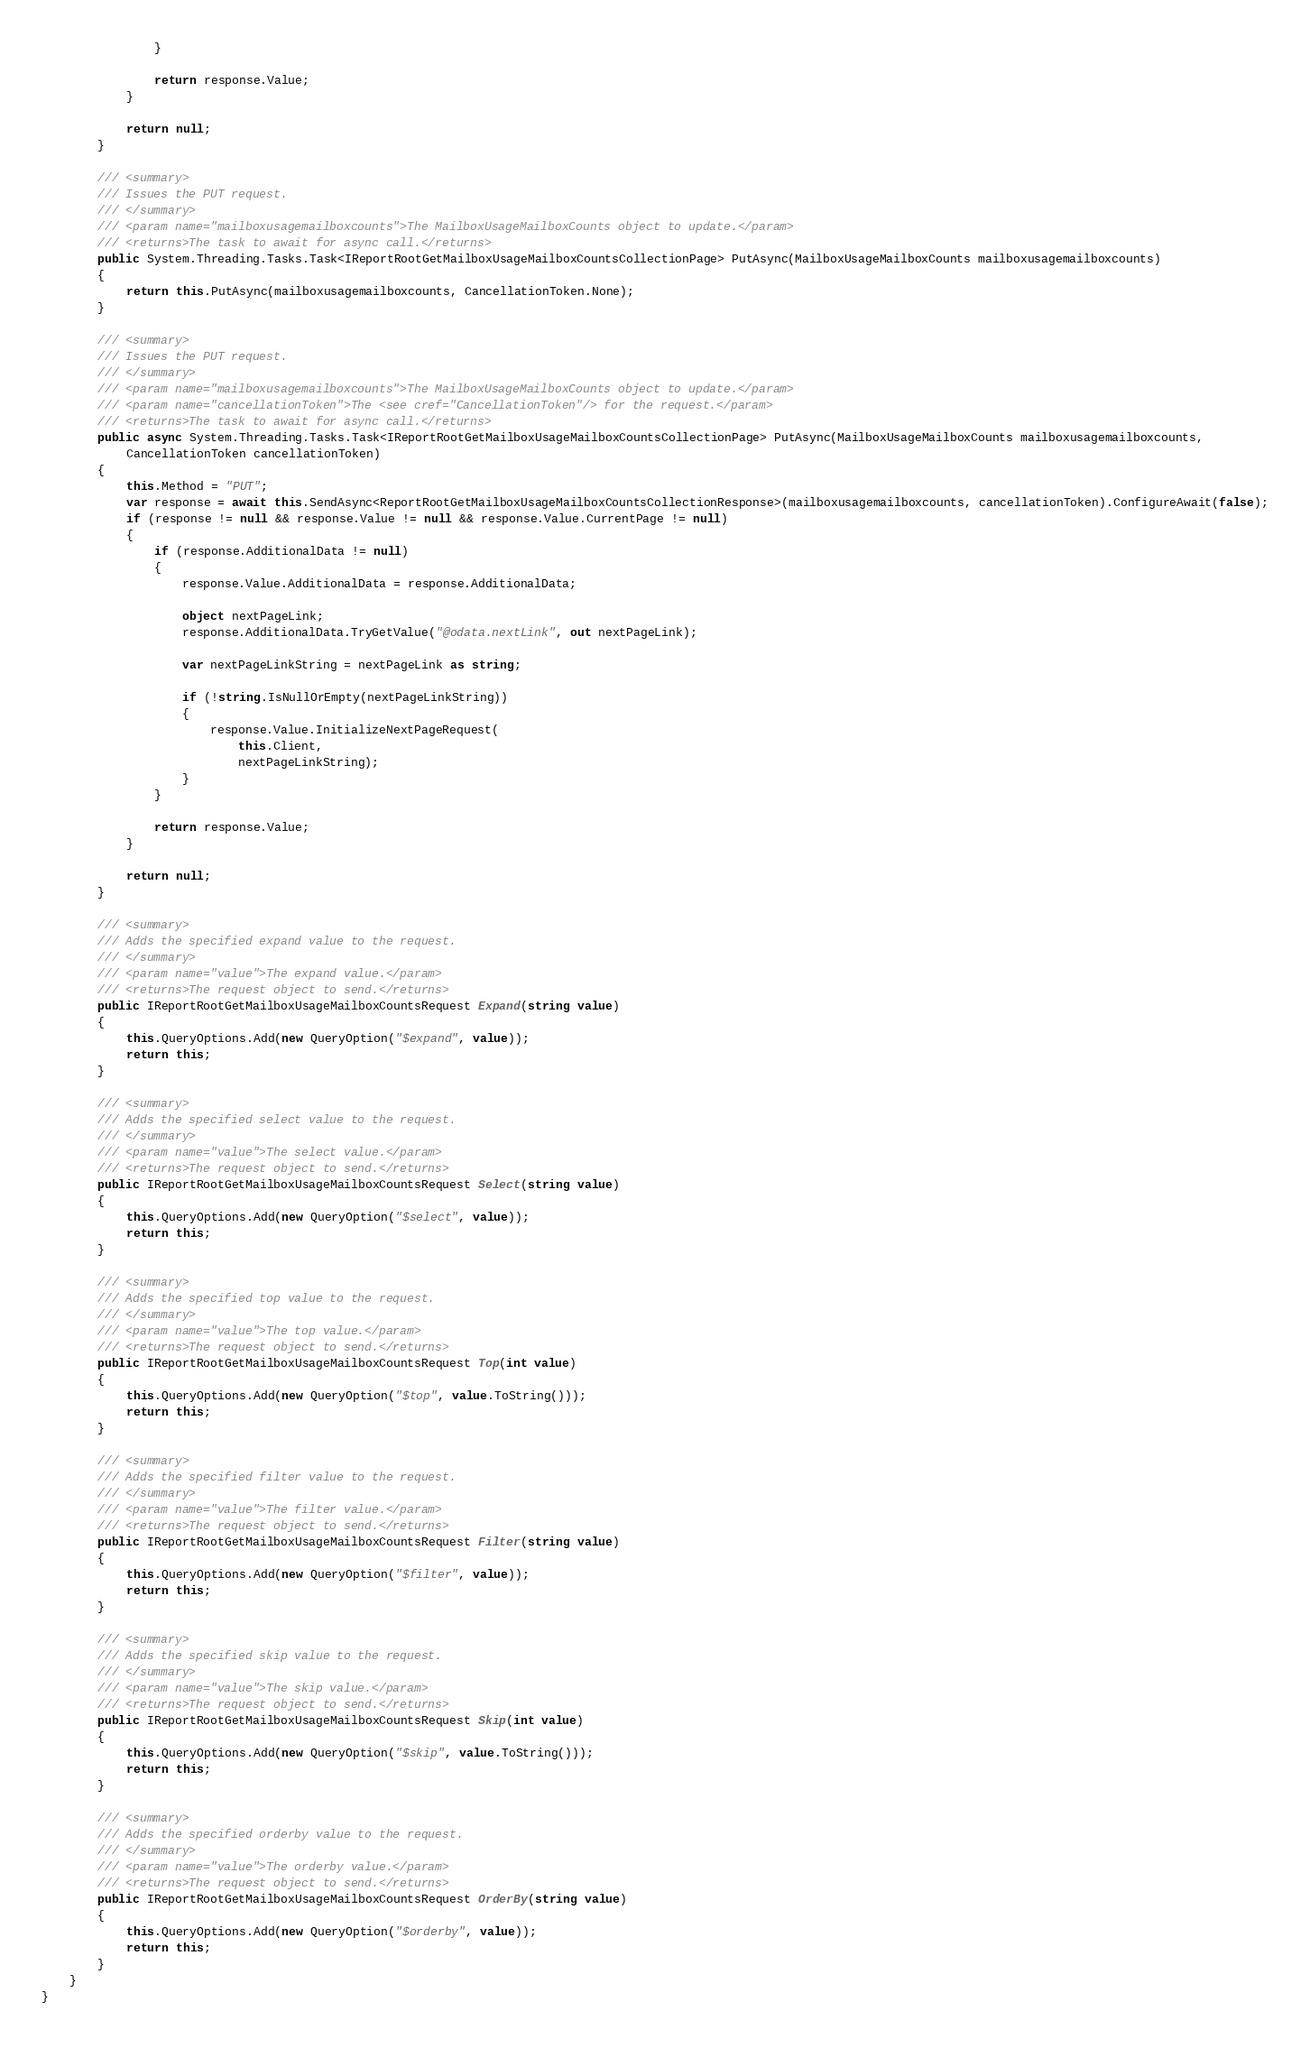Convert code to text. <code><loc_0><loc_0><loc_500><loc_500><_C#_>                }

                return response.Value;
            }

            return null;
        }        

        /// <summary>
        /// Issues the PUT request.
        /// </summary>
        /// <param name="mailboxusagemailboxcounts">The MailboxUsageMailboxCounts object to update.</param>
        /// <returns>The task to await for async call.</returns>
        public System.Threading.Tasks.Task<IReportRootGetMailboxUsageMailboxCountsCollectionPage> PutAsync(MailboxUsageMailboxCounts mailboxusagemailboxcounts)
        {
            return this.PutAsync(mailboxusagemailboxcounts, CancellationToken.None);
        }

        /// <summary>
        /// Issues the PUT request.
        /// </summary>
        /// <param name="mailboxusagemailboxcounts">The MailboxUsageMailboxCounts object to update.</param>
        /// <param name="cancellationToken">The <see cref="CancellationToken"/> for the request.</param>
        /// <returns>The task to await for async call.</returns>
        public async System.Threading.Tasks.Task<IReportRootGetMailboxUsageMailboxCountsCollectionPage> PutAsync(MailboxUsageMailboxCounts mailboxusagemailboxcounts, 
            CancellationToken cancellationToken)
        {
            this.Method = "PUT";
            var response = await this.SendAsync<ReportRootGetMailboxUsageMailboxCountsCollectionResponse>(mailboxusagemailboxcounts, cancellationToken).ConfigureAwait(false);
            if (response != null && response.Value != null && response.Value.CurrentPage != null)
            {
                if (response.AdditionalData != null)
                {
                    response.Value.AdditionalData = response.AdditionalData;

                    object nextPageLink;
                    response.AdditionalData.TryGetValue("@odata.nextLink", out nextPageLink);

                    var nextPageLinkString = nextPageLink as string;

                    if (!string.IsNullOrEmpty(nextPageLinkString))
                    {
                        response.Value.InitializeNextPageRequest(
                            this.Client,
                            nextPageLinkString);
                    }
                }

                return response.Value;
            }

            return null;
        }        

        /// <summary>
        /// Adds the specified expand value to the request.
        /// </summary>
        /// <param name="value">The expand value.</param>
        /// <returns>The request object to send.</returns>
        public IReportRootGetMailboxUsageMailboxCountsRequest Expand(string value)
        {
            this.QueryOptions.Add(new QueryOption("$expand", value));
            return this;
        }

        /// <summary>
        /// Adds the specified select value to the request.
        /// </summary>
        /// <param name="value">The select value.</param>
        /// <returns>The request object to send.</returns>
        public IReportRootGetMailboxUsageMailboxCountsRequest Select(string value)
        {
            this.QueryOptions.Add(new QueryOption("$select", value));
            return this;
        }

        /// <summary>
        /// Adds the specified top value to the request.
        /// </summary>
        /// <param name="value">The top value.</param>
        /// <returns>The request object to send.</returns>
        public IReportRootGetMailboxUsageMailboxCountsRequest Top(int value)
        {
            this.QueryOptions.Add(new QueryOption("$top", value.ToString()));
            return this;
        }

        /// <summary>
        /// Adds the specified filter value to the request.
        /// </summary>
        /// <param name="value">The filter value.</param>
        /// <returns>The request object to send.</returns>
        public IReportRootGetMailboxUsageMailboxCountsRequest Filter(string value)
        {
            this.QueryOptions.Add(new QueryOption("$filter", value));
            return this;
        }

        /// <summary>
        /// Adds the specified skip value to the request.
        /// </summary>
        /// <param name="value">The skip value.</param>
        /// <returns>The request object to send.</returns>
        public IReportRootGetMailboxUsageMailboxCountsRequest Skip(int value)
        {
            this.QueryOptions.Add(new QueryOption("$skip", value.ToString()));
            return this;
        }

        /// <summary>
        /// Adds the specified orderby value to the request.
        /// </summary>
        /// <param name="value">The orderby value.</param>
        /// <returns>The request object to send.</returns>
        public IReportRootGetMailboxUsageMailboxCountsRequest OrderBy(string value)
        {
            this.QueryOptions.Add(new QueryOption("$orderby", value));
            return this;
        }
    }
}
</code> 